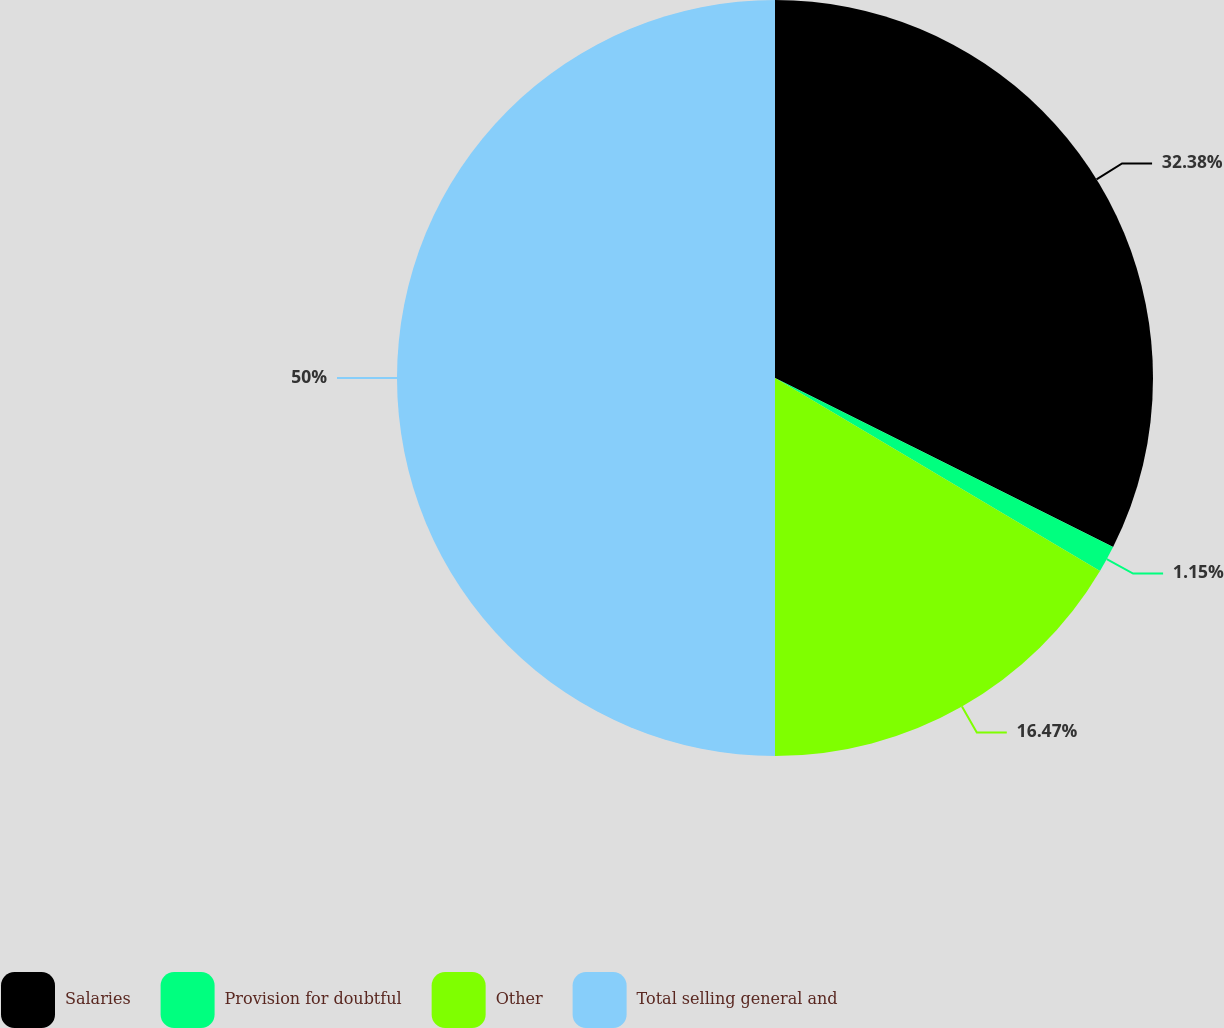<chart> <loc_0><loc_0><loc_500><loc_500><pie_chart><fcel>Salaries<fcel>Provision for doubtful<fcel>Other<fcel>Total selling general and<nl><fcel>32.38%<fcel>1.15%<fcel>16.47%<fcel>50.0%<nl></chart> 